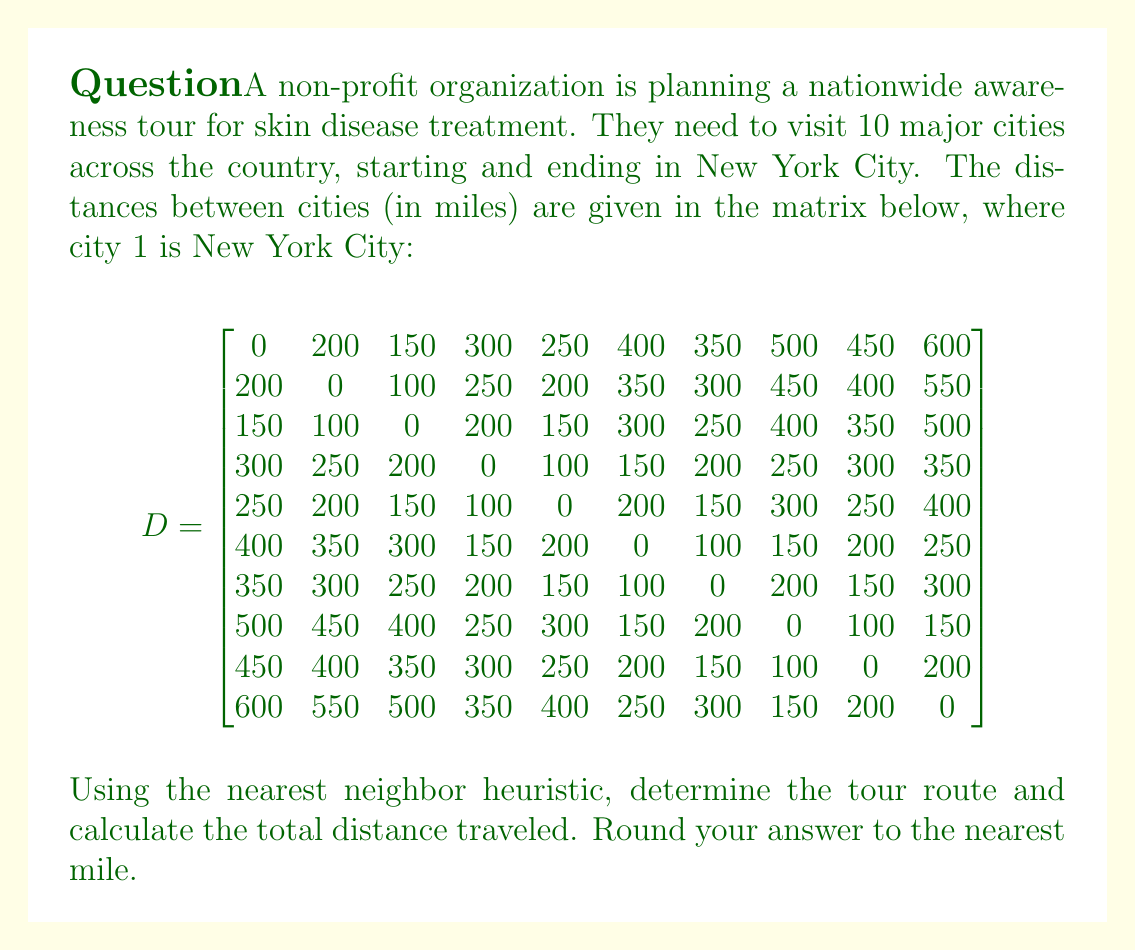Can you solve this math problem? To solve this problem, we'll use the nearest neighbor heuristic, which is a greedy algorithm for solving the Traveling Salesman Problem. Here's how it works:

1. Start with the first city (New York City, index 1).
2. Find the nearest unvisited city and move to it.
3. Repeat step 2 until all cities have been visited.
4. Return to the starting city.

Let's apply this algorithm:

1. Start: New York City (1)
2. Nearest to 1: City 3 (150 miles)
3. Nearest to 3: City 5 (150 miles)
4. Nearest to 5: City 4 (100 miles)
5. Nearest to 4: City 6 (150 miles)
6. Nearest to 6: City 7 (100 miles)
7. Nearest to 7: City 9 (150 miles)
8. Nearest to 9: City 8 (100 miles)
9. Nearest to 8: City 10 (150 miles)
10. Nearest to 10: City 2 (550 miles)
11. Return to New York City (1) from City 2 (200 miles)

Now, let's calculate the total distance:

$$
\begin{align*}
\text{Total Distance} &= 150 + 150 + 100 + 150 + 100 + 150 + 100 + 150 + 550 + 200 \\
&= 1800 \text{ miles}
\end{align*}
$$

Therefore, the tour route is 1 → 3 → 5 → 4 → 6 → 7 → 9 → 8 → 10 → 2 → 1, and the total distance traveled is 1800 miles.
Answer: The tour route is 1 → 3 → 5 → 4 → 6 → 7 → 9 → 8 → 10 → 2 → 1, and the total distance traveled is 1800 miles. 